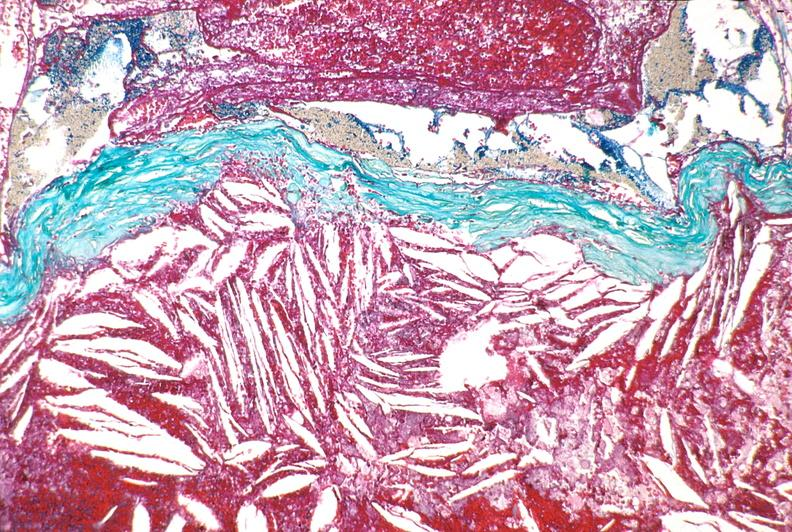what does this image show?
Answer the question using a single word or phrase. Right coronary artery 